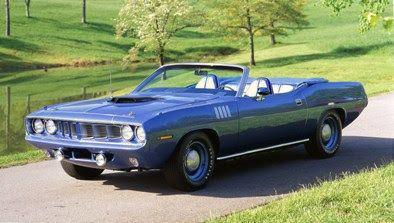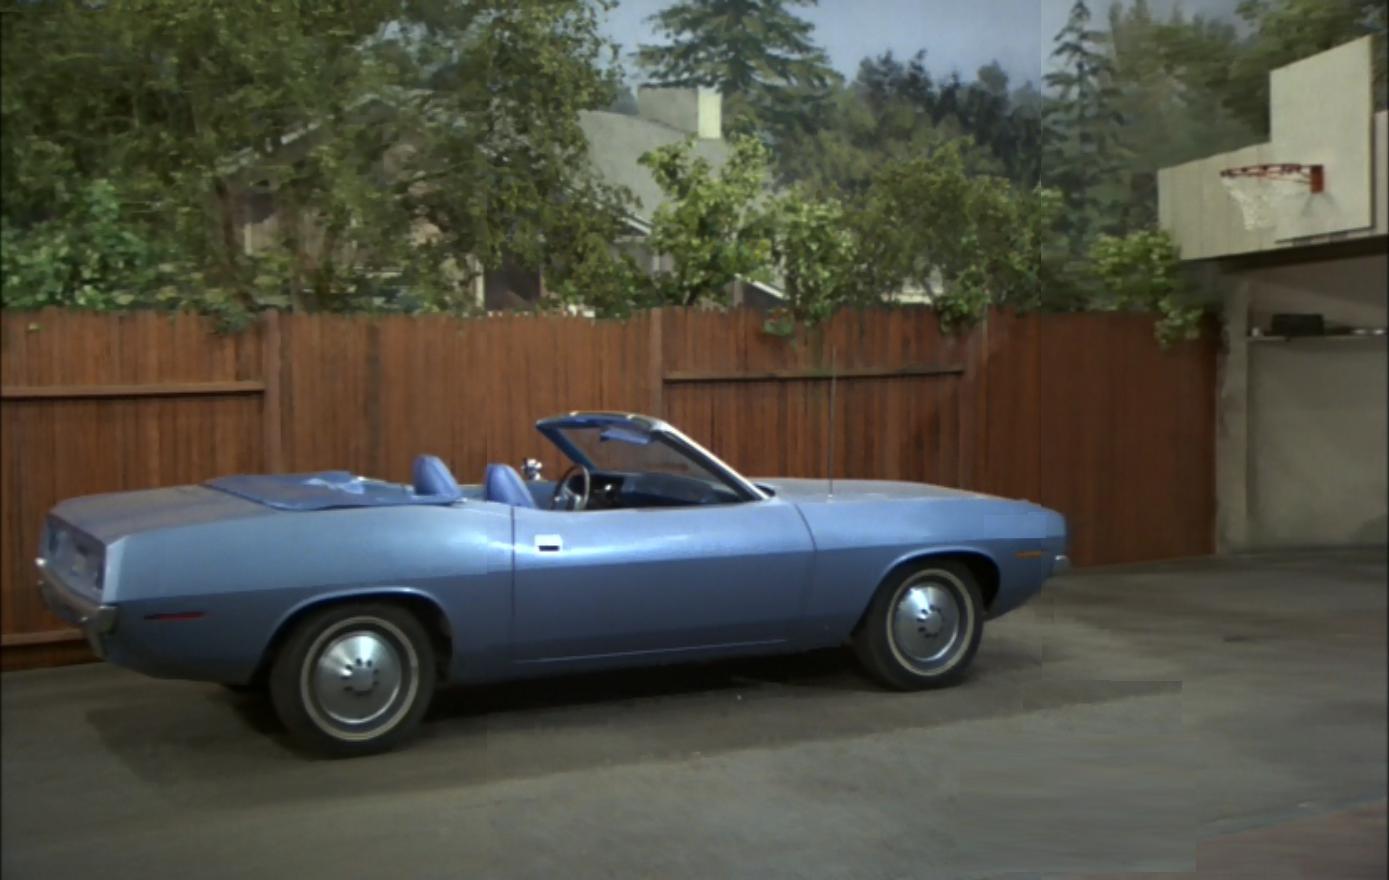The first image is the image on the left, the second image is the image on the right. Evaluate the accuracy of this statement regarding the images: "Each image shows a person behind the wheel of a convertible.". Is it true? Answer yes or no. No. The first image is the image on the left, the second image is the image on the right. Analyze the images presented: Is the assertion "All of the cars in the images are sky blue." valid? Answer yes or no. Yes. 